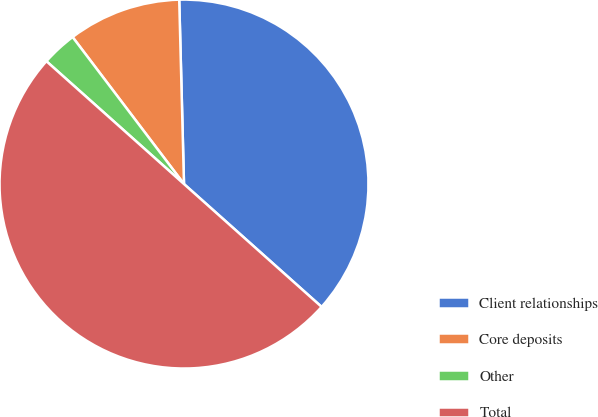Convert chart to OTSL. <chart><loc_0><loc_0><loc_500><loc_500><pie_chart><fcel>Client relationships<fcel>Core deposits<fcel>Other<fcel>Total<nl><fcel>37.01%<fcel>9.91%<fcel>3.08%<fcel>50.0%<nl></chart> 